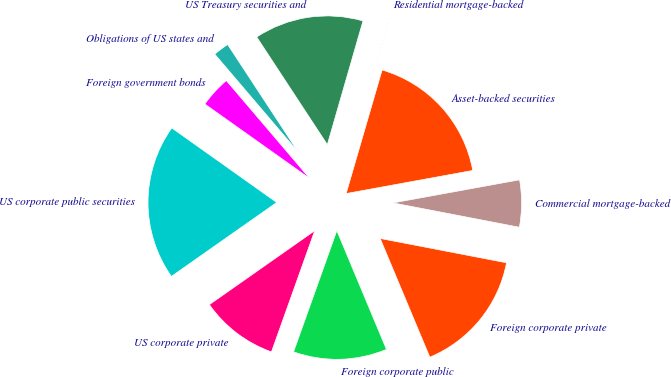Convert chart. <chart><loc_0><loc_0><loc_500><loc_500><pie_chart><fcel>US Treasury securities and<fcel>Obligations of US states and<fcel>Foreign government bonds<fcel>US corporate public securities<fcel>US corporate private<fcel>Foreign corporate public<fcel>Foreign corporate private<fcel>Commercial mortgage-backed<fcel>Asset-backed securities<fcel>Residential mortgage-backed<nl><fcel>13.71%<fcel>1.99%<fcel>3.94%<fcel>19.57%<fcel>9.8%<fcel>11.76%<fcel>15.67%<fcel>5.9%<fcel>17.62%<fcel>0.04%<nl></chart> 